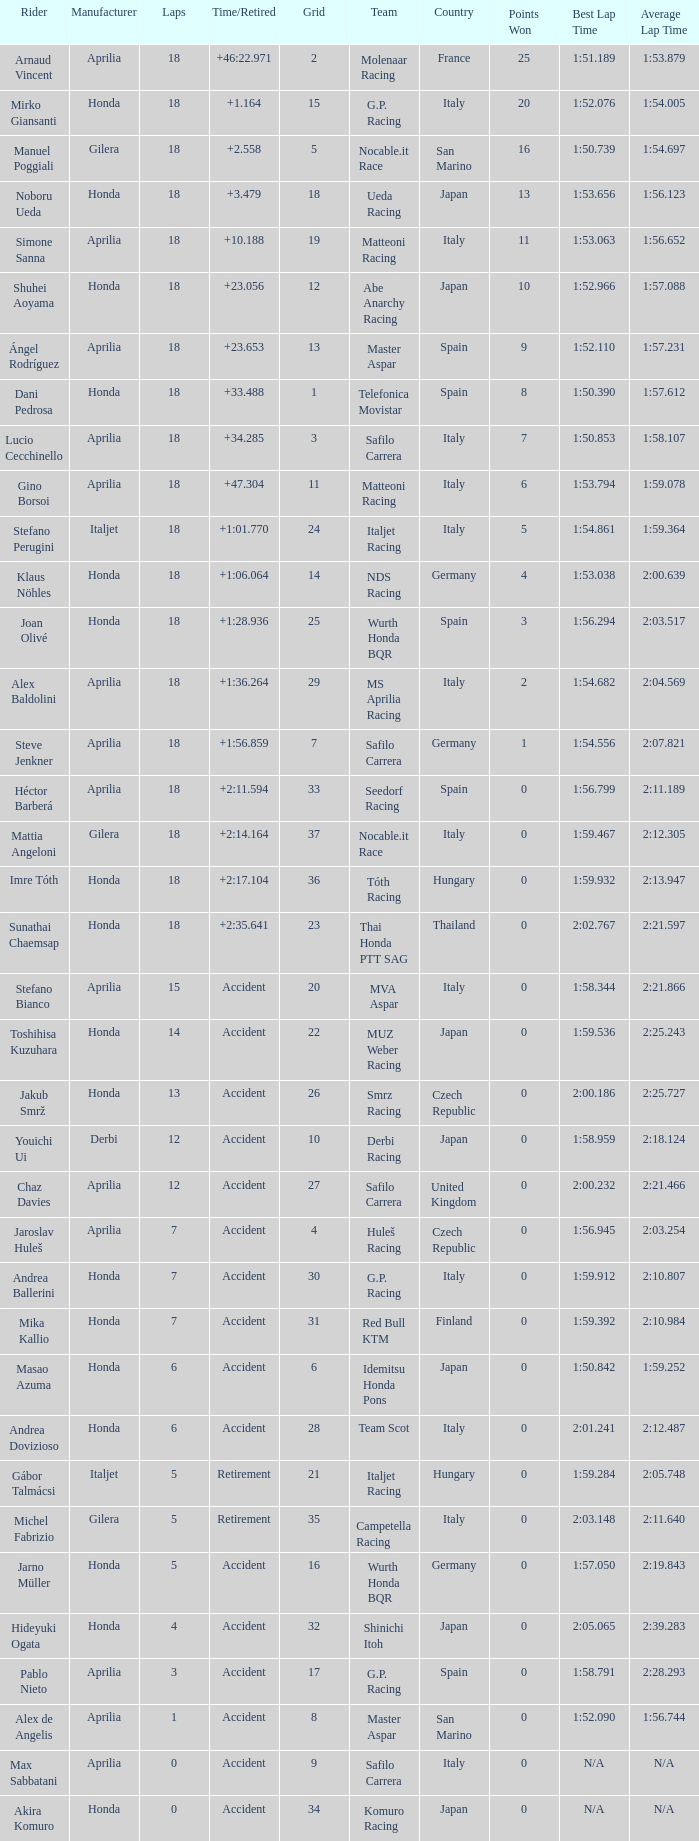Who is the rider with less than 15 laps, more than 32 grids, and an accident time/retired? Akira Komuro. 